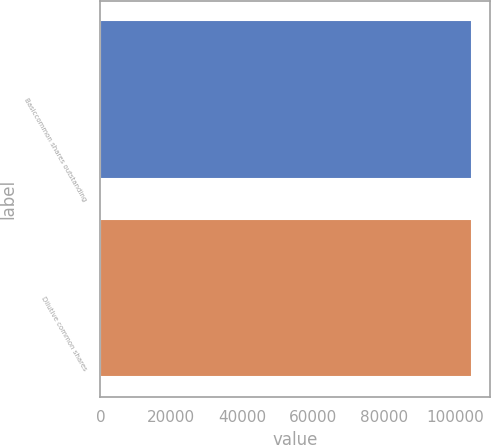Convert chart to OTSL. <chart><loc_0><loc_0><loc_500><loc_500><bar_chart><fcel>Basiccommon shares outstanding<fcel>Dilutive common shares<nl><fcel>104628<fcel>104628<nl></chart> 